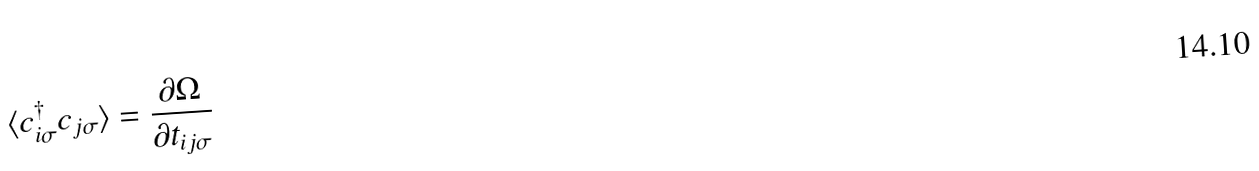Convert formula to latex. <formula><loc_0><loc_0><loc_500><loc_500>\langle c _ { i \sigma } ^ { \dagger } c _ { j \sigma } \rangle = \frac { \partial \Omega } { \partial t _ { i j \sigma } }</formula> 